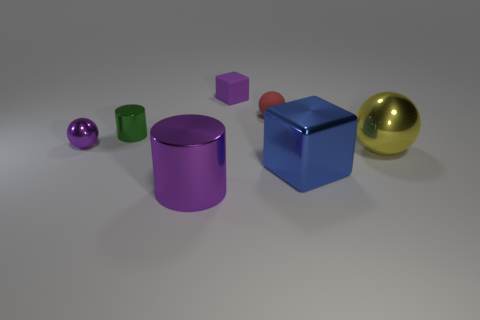How many objects are there, and can you describe their shapes? In the image, there are six distinct objects, each with a unique shape. Starting from the left, there's a small purple sphere, followed by a larger green cylinder, next a purple cylinder, a small red cube, a blue cube, and finally, a large gold sphere on the right. Their geometric shapes add variety to the scene. 